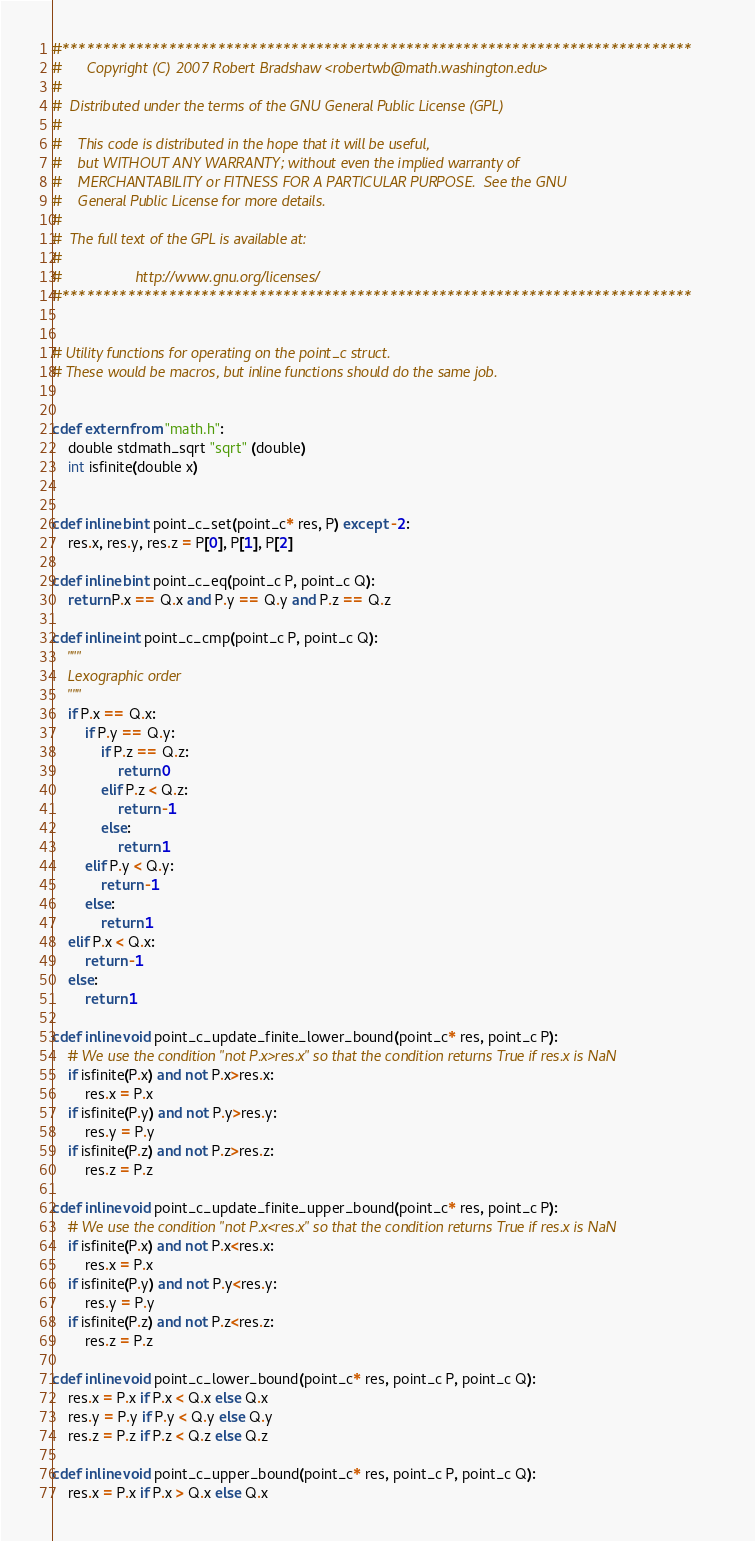Convert code to text. <code><loc_0><loc_0><loc_500><loc_500><_Cython_>#*****************************************************************************
#      Copyright (C) 2007 Robert Bradshaw <robertwb@math.washington.edu>
#
#  Distributed under the terms of the GNU General Public License (GPL)
#
#    This code is distributed in the hope that it will be useful,
#    but WITHOUT ANY WARRANTY; without even the implied warranty of
#    MERCHANTABILITY or FITNESS FOR A PARTICULAR PURPOSE.  See the GNU
#    General Public License for more details.
#
#  The full text of the GPL is available at:
#
#                  http://www.gnu.org/licenses/
#*****************************************************************************


# Utility functions for operating on the point_c struct.
# These would be macros, but inline functions should do the same job.


cdef extern from "math.h":
    double stdmath_sqrt "sqrt" (double)
    int isfinite(double x)


cdef inline bint point_c_set(point_c* res, P) except -2:
    res.x, res.y, res.z = P[0], P[1], P[2]

cdef inline bint point_c_eq(point_c P, point_c Q):
    return P.x == Q.x and P.y == Q.y and P.z == Q.z

cdef inline int point_c_cmp(point_c P, point_c Q):
    """
    Lexographic order
    """
    if P.x == Q.x:
        if P.y == Q.y:
            if P.z == Q.z:
                return 0
            elif P.z < Q.z:
                return -1
            else:
                return 1
        elif P.y < Q.y:
            return -1
        else:
            return 1
    elif P.x < Q.x:
        return -1
    else:
        return 1

cdef inline void point_c_update_finite_lower_bound(point_c* res, point_c P):
    # We use the condition "not P.x>res.x" so that the condition returns True if res.x is NaN
    if isfinite(P.x) and not P.x>res.x:
        res.x = P.x
    if isfinite(P.y) and not P.y>res.y:
        res.y = P.y
    if isfinite(P.z) and not P.z>res.z:
        res.z = P.z

cdef inline void point_c_update_finite_upper_bound(point_c* res, point_c P):
    # We use the condition "not P.x<res.x" so that the condition returns True if res.x is NaN
    if isfinite(P.x) and not P.x<res.x:
        res.x = P.x
    if isfinite(P.y) and not P.y<res.y:
        res.y = P.y
    if isfinite(P.z) and not P.z<res.z:
        res.z = P.z

cdef inline void point_c_lower_bound(point_c* res, point_c P, point_c Q):
    res.x = P.x if P.x < Q.x else Q.x
    res.y = P.y if P.y < Q.y else Q.y
    res.z = P.z if P.z < Q.z else Q.z

cdef inline void point_c_upper_bound(point_c* res, point_c P, point_c Q):
    res.x = P.x if P.x > Q.x else Q.x</code> 